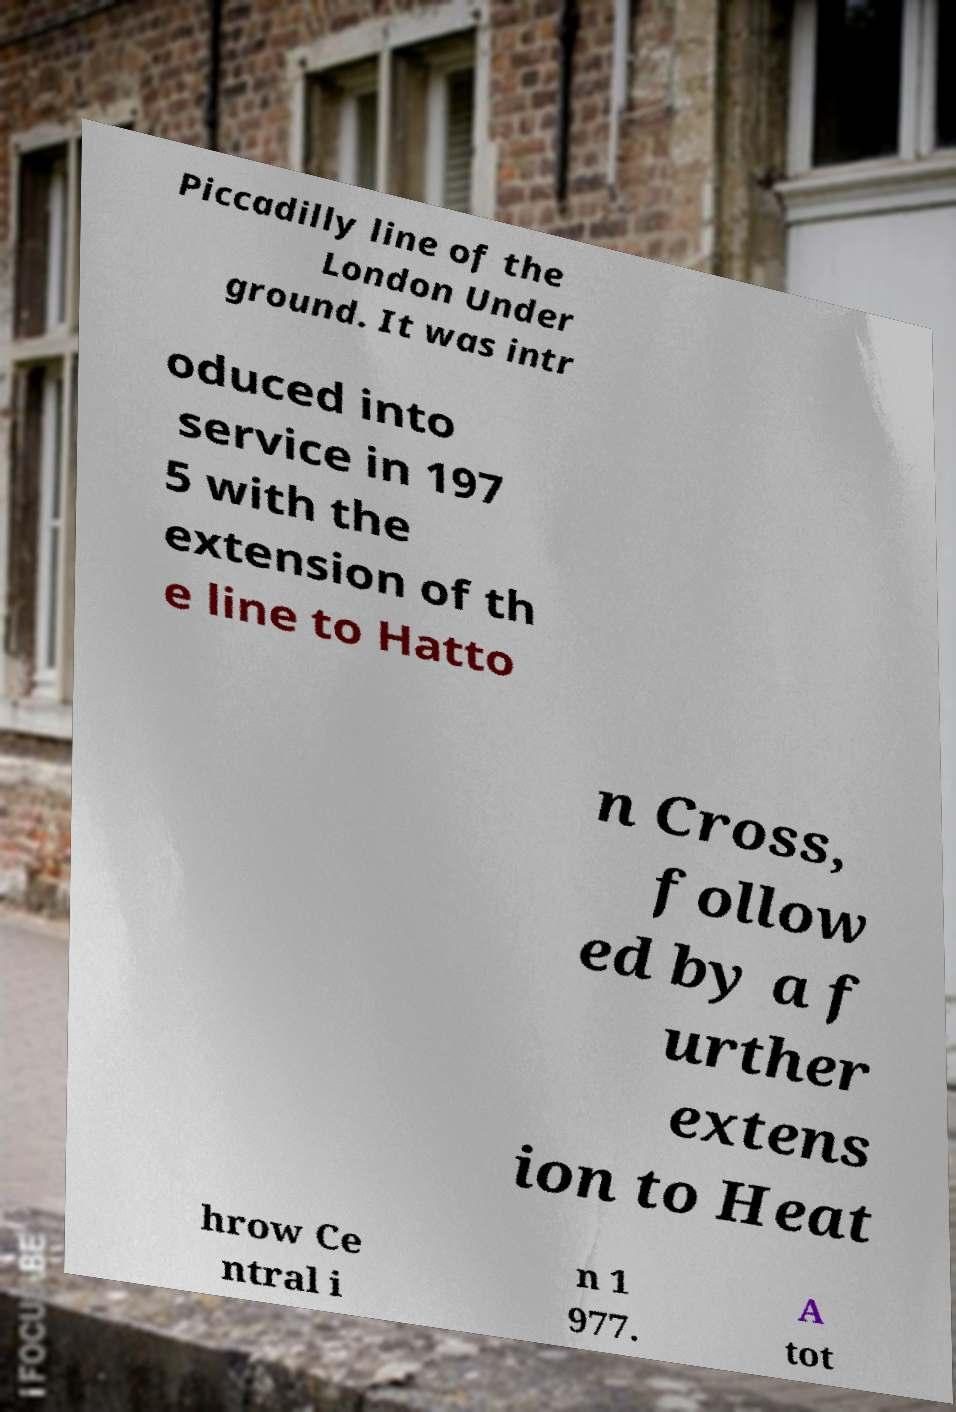What messages or text are displayed in this image? I need them in a readable, typed format. Piccadilly line of the London Under ground. It was intr oduced into service in 197 5 with the extension of th e line to Hatto n Cross, follow ed by a f urther extens ion to Heat hrow Ce ntral i n 1 977. A tot 